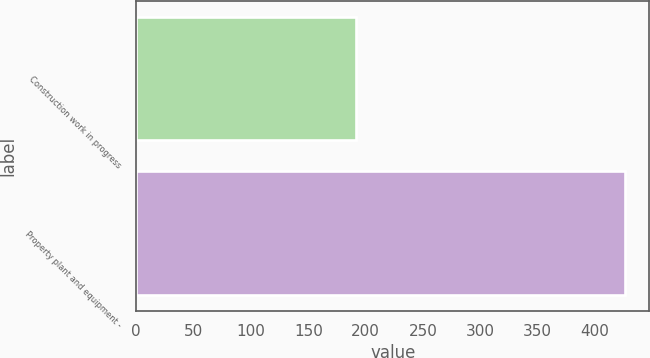Convert chart to OTSL. <chart><loc_0><loc_0><loc_500><loc_500><bar_chart><fcel>Construction work in progress<fcel>Property plant and equipment -<nl><fcel>192<fcel>426<nl></chart> 